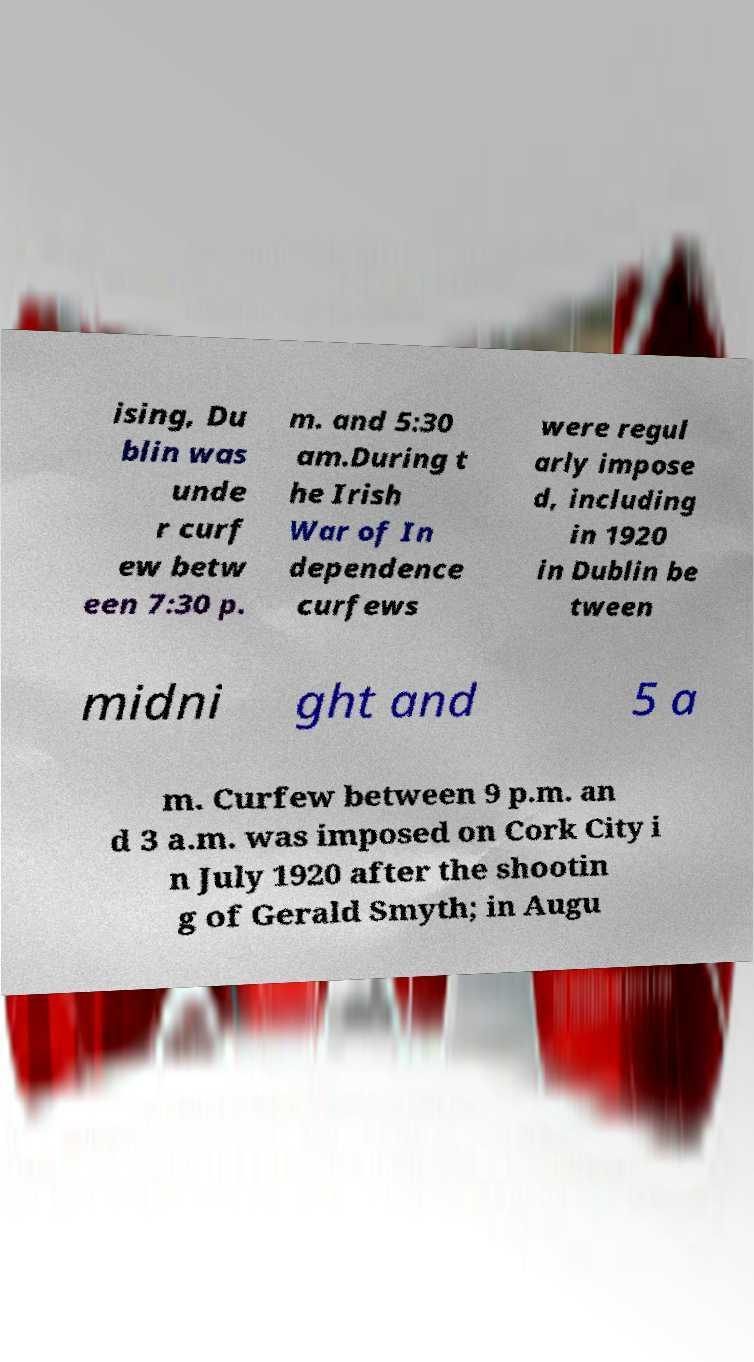For documentation purposes, I need the text within this image transcribed. Could you provide that? ising, Du blin was unde r curf ew betw een 7:30 p. m. and 5:30 am.During t he Irish War of In dependence curfews were regul arly impose d, including in 1920 in Dublin be tween midni ght and 5 a m. Curfew between 9 p.m. an d 3 a.m. was imposed on Cork City i n July 1920 after the shootin g of Gerald Smyth; in Augu 